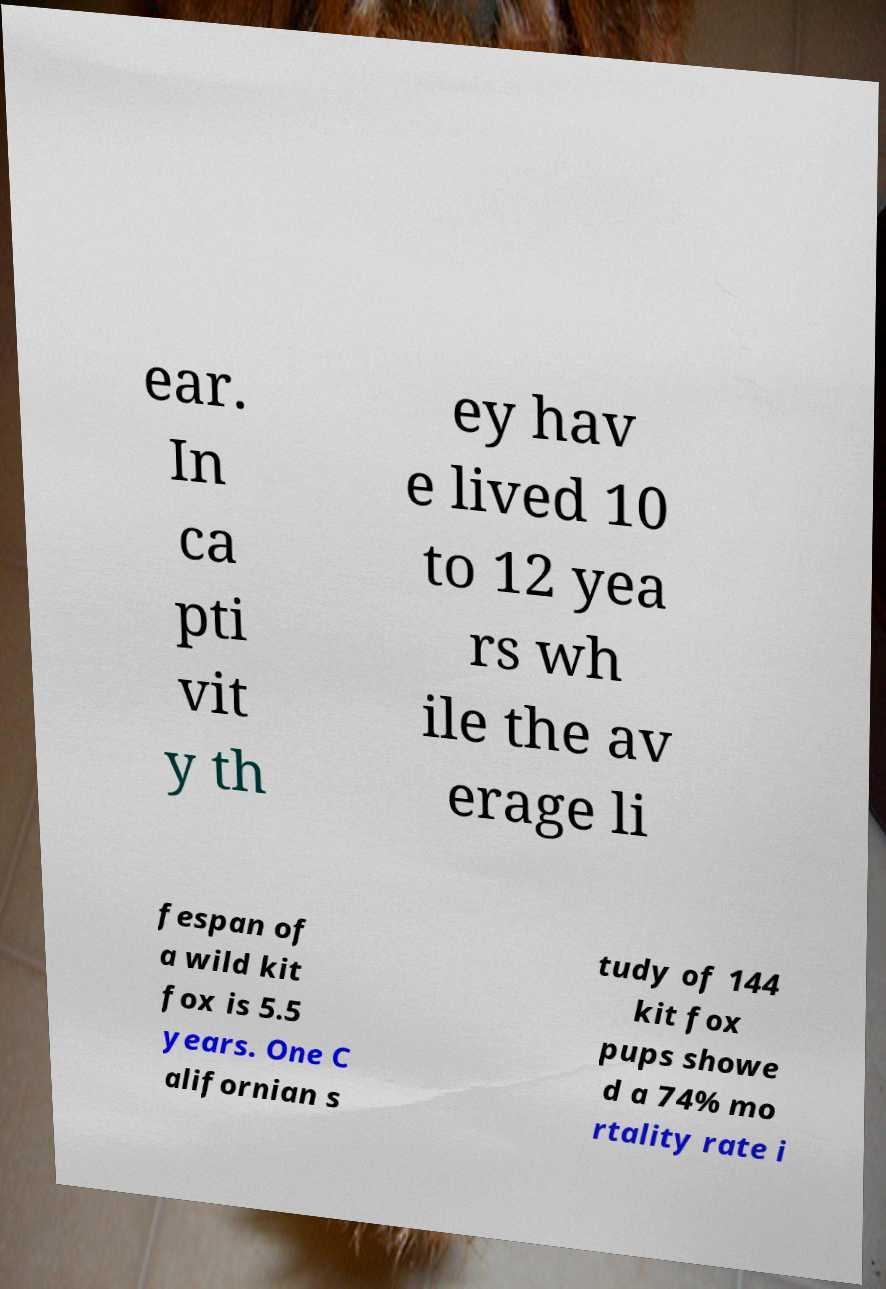Could you extract and type out the text from this image? ear. In ca pti vit y th ey hav e lived 10 to 12 yea rs wh ile the av erage li fespan of a wild kit fox is 5.5 years. One C alifornian s tudy of 144 kit fox pups showe d a 74% mo rtality rate i 